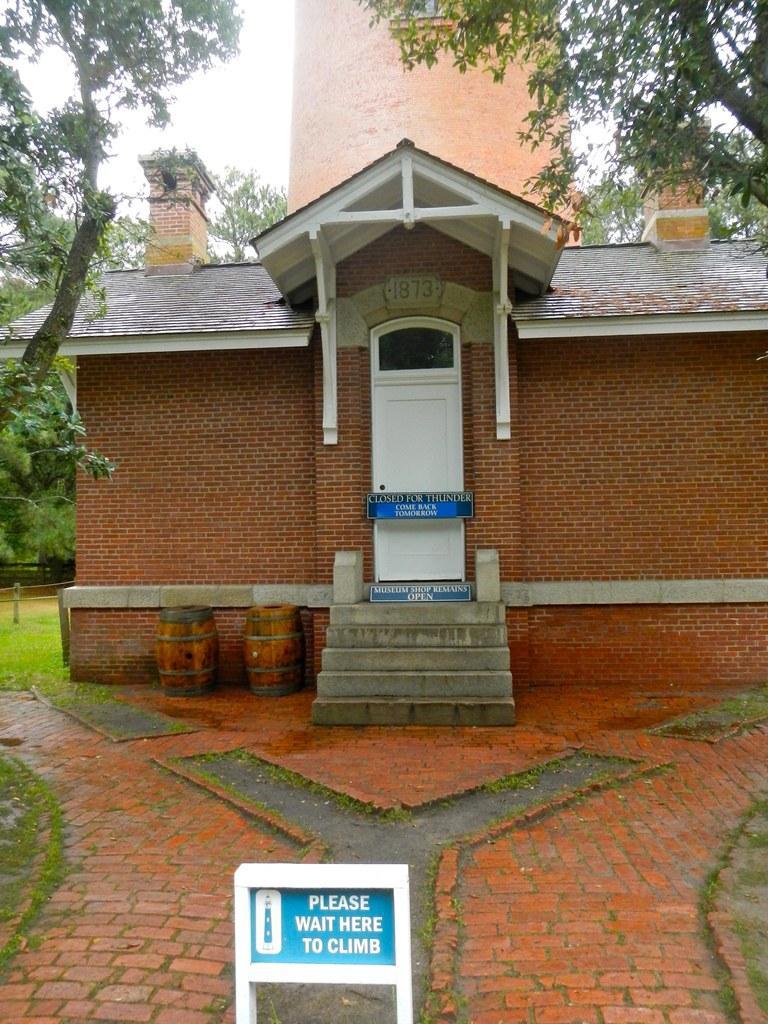Can you describe this image briefly? In this picture I can see boards, a house, barrels, grass, trees, it looks like a tower, and in the background there is sky. 